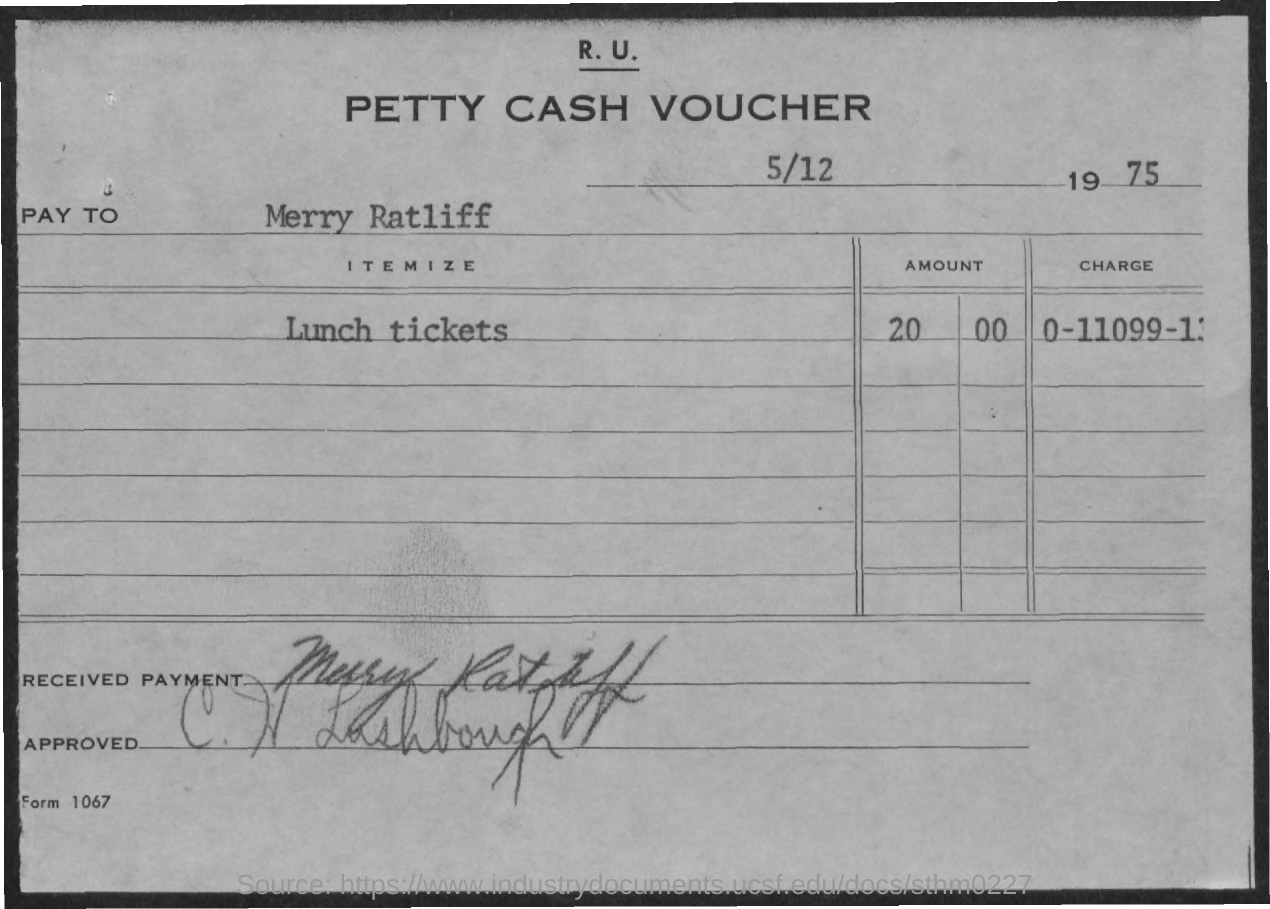What is the form number?
Keep it short and to the point. 1067. Who received the payment?
Your response must be concise. Merry Ratliff. 